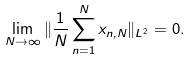<formula> <loc_0><loc_0><loc_500><loc_500>\lim _ { N \to \infty } \| \frac { 1 } { N } \sum _ { n = 1 } ^ { N } x _ { n , N } \| _ { L ^ { 2 } } = 0 .</formula> 